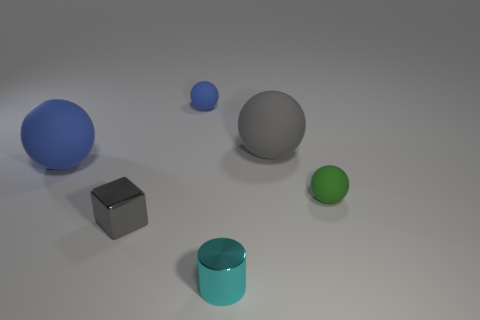The tiny gray object in front of the blue matte object left of the tiny matte ball to the left of the big gray matte ball is made of what material?
Make the answer very short. Metal. Is the shape of the small blue matte object the same as the small gray thing that is behind the cyan metal object?
Give a very brief answer. No. What number of large blue things have the same shape as the gray rubber thing?
Provide a succinct answer. 1. The big blue thing has what shape?
Give a very brief answer. Sphere. There is a cyan thing that is in front of the blue sphere that is behind the big blue rubber thing; what size is it?
Provide a short and direct response. Small. Is the shape of the big gray matte object the same as the small green rubber thing?
Keep it short and to the point. Yes. There is a blue rubber sphere that is on the left side of the gray metal thing; is there a gray metal thing that is to the left of it?
Ensure brevity in your answer.  No. Do the gray object that is in front of the green ball and the tiny green matte ball have the same size?
Offer a terse response. Yes. There is a object that is in front of the big blue matte sphere and behind the small cube; how big is it?
Provide a succinct answer. Small. What shape is the small object that is left of the cyan metal object and in front of the big gray sphere?
Make the answer very short. Cube. 